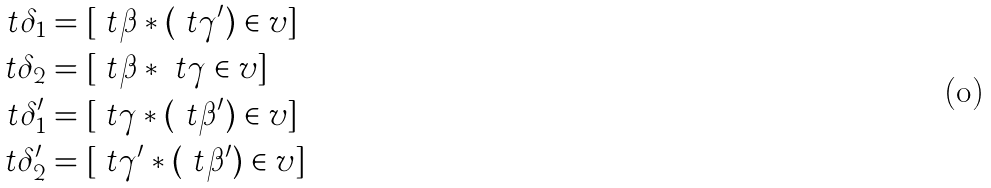Convert formula to latex. <formula><loc_0><loc_0><loc_500><loc_500>\ t { \delta } _ { 1 } & = [ \ t { \beta } * ( \ t { \gamma } ^ { \prime } ) \in v ] \\ \ t { \delta } _ { 2 } & = [ \ t { \beta } * \ t { \gamma } \in v ] \\ \quad \ t { \delta } _ { 1 } ^ { \prime } & = [ \ t { \gamma } * ( \ t { \beta } ^ { \prime } ) \in v ] \\ \ t { \delta } _ { 2 } ^ { \prime } & = [ \ t { \gamma } ^ { \prime } * ( \ t { \beta } ^ { \prime } ) \in v ]</formula> 